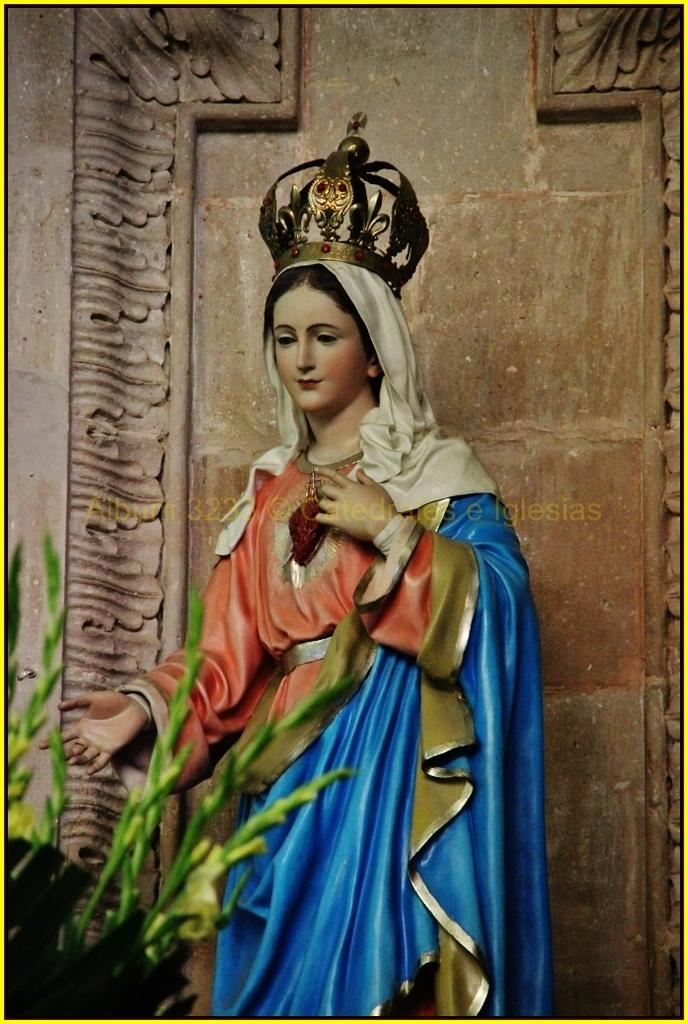What is the main subject of the image? There is a statue of a woman in the image. What is the woman wearing or holding on her head? The woman has a crown on her head. What can be seen on the left side of the image? There is a plant on the left side of the image. What is visible in the background of the image? There is a wall in the background of the image. What type of nut is being cracked by the horse in the image? There is no horse or nut present in the image; it features a statue of a woman with a crown and a plant on the left side. 